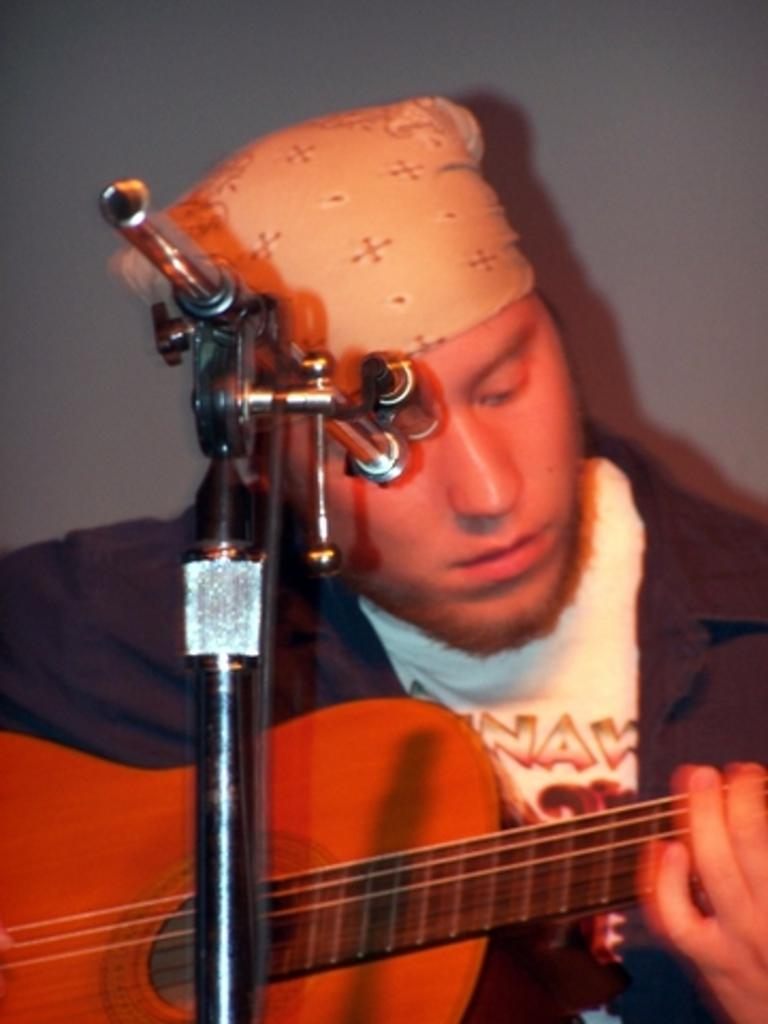What is the man in the image holding? The man is holding a guitar. What is in front of the man? There is a stand in front of the man. How many legs does the wax figure have in the image? There is no wax figure present in the image, so it is not possible to determine the number of legs it might have. 